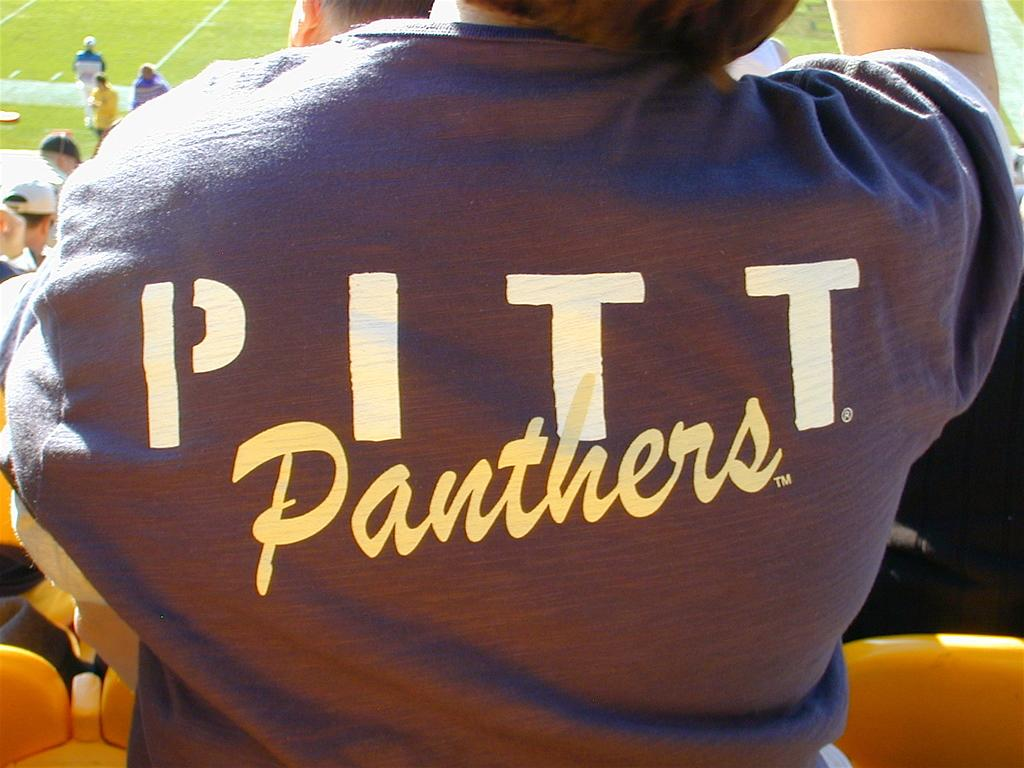What is happening in the image? There are people standing in the image. What are the people standing near? There are chairs in front of the people. Are there any people in a specific area of the image? Yes, there are people standing in the top left corner of the image. What type of natural environment is visible in the image? There is grass visible behind the people. What type of mint plant can be seen growing in the garden in the image? There is no garden or mint plant present in the image. 